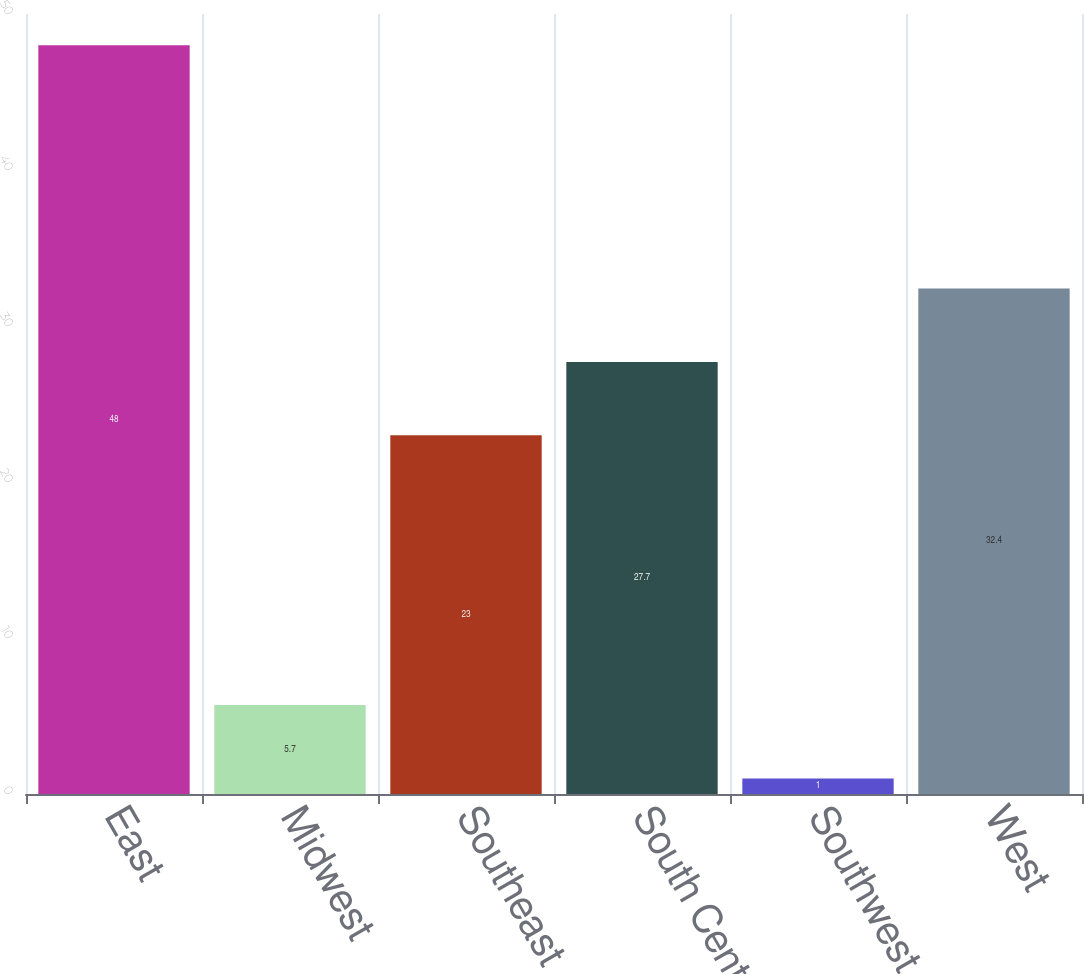Convert chart to OTSL. <chart><loc_0><loc_0><loc_500><loc_500><bar_chart><fcel>East<fcel>Midwest<fcel>Southeast<fcel>South Central<fcel>Southwest<fcel>West<nl><fcel>48<fcel>5.7<fcel>23<fcel>27.7<fcel>1<fcel>32.4<nl></chart> 